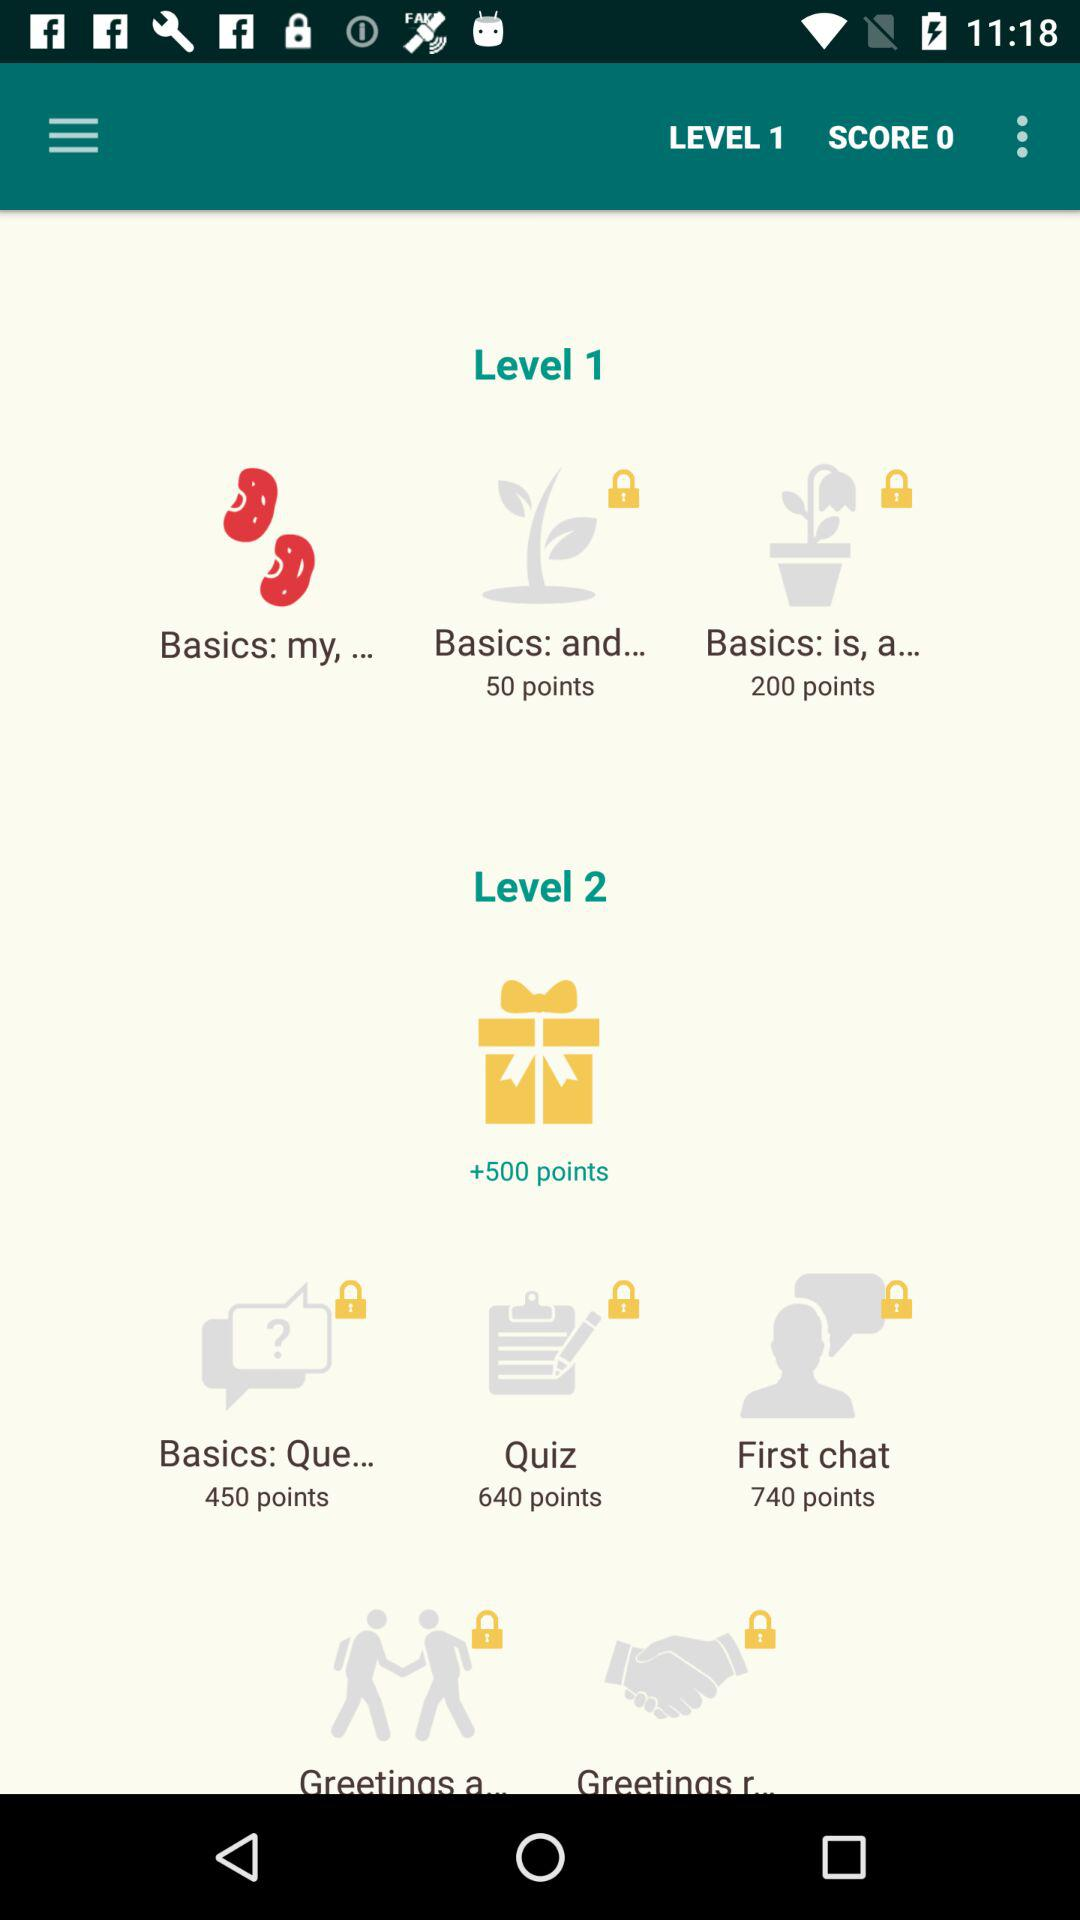How many points are there in the Basics: Que? There are 450 points in the Basics: Que. 